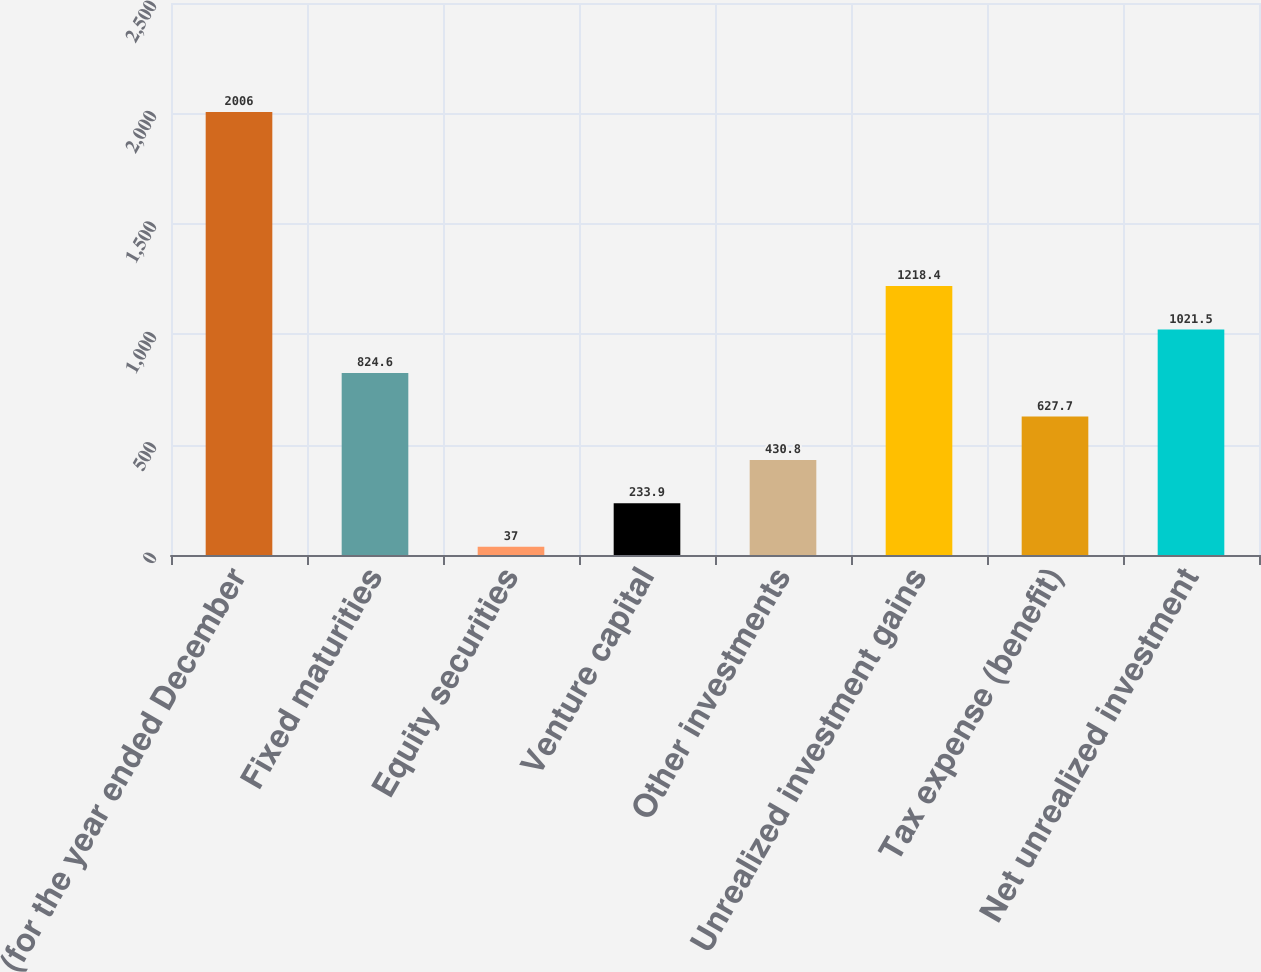Convert chart to OTSL. <chart><loc_0><loc_0><loc_500><loc_500><bar_chart><fcel>(for the year ended December<fcel>Fixed maturities<fcel>Equity securities<fcel>Venture capital<fcel>Other investments<fcel>Unrealized investment gains<fcel>Tax expense (benefit)<fcel>Net unrealized investment<nl><fcel>2006<fcel>824.6<fcel>37<fcel>233.9<fcel>430.8<fcel>1218.4<fcel>627.7<fcel>1021.5<nl></chart> 